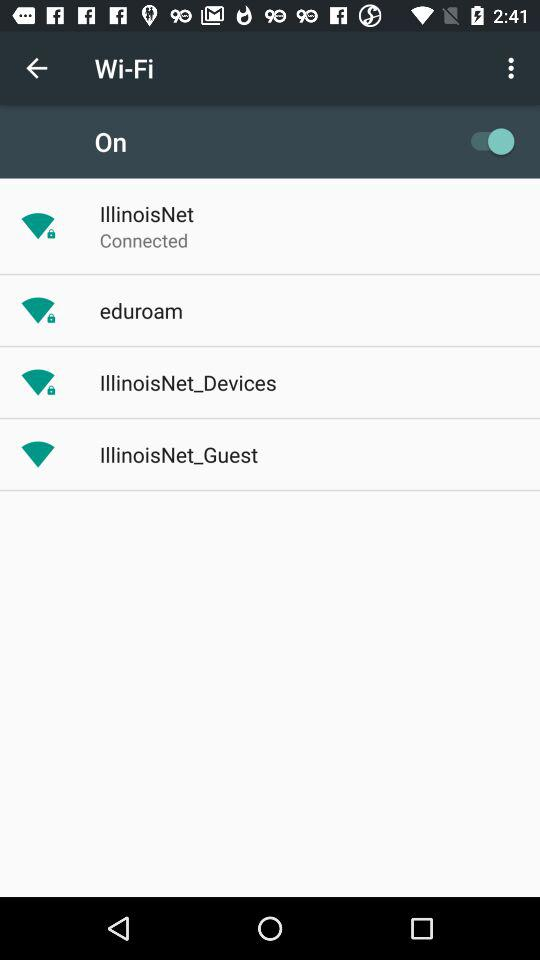What is the status of "Wi-Fi"? The status is "on". 